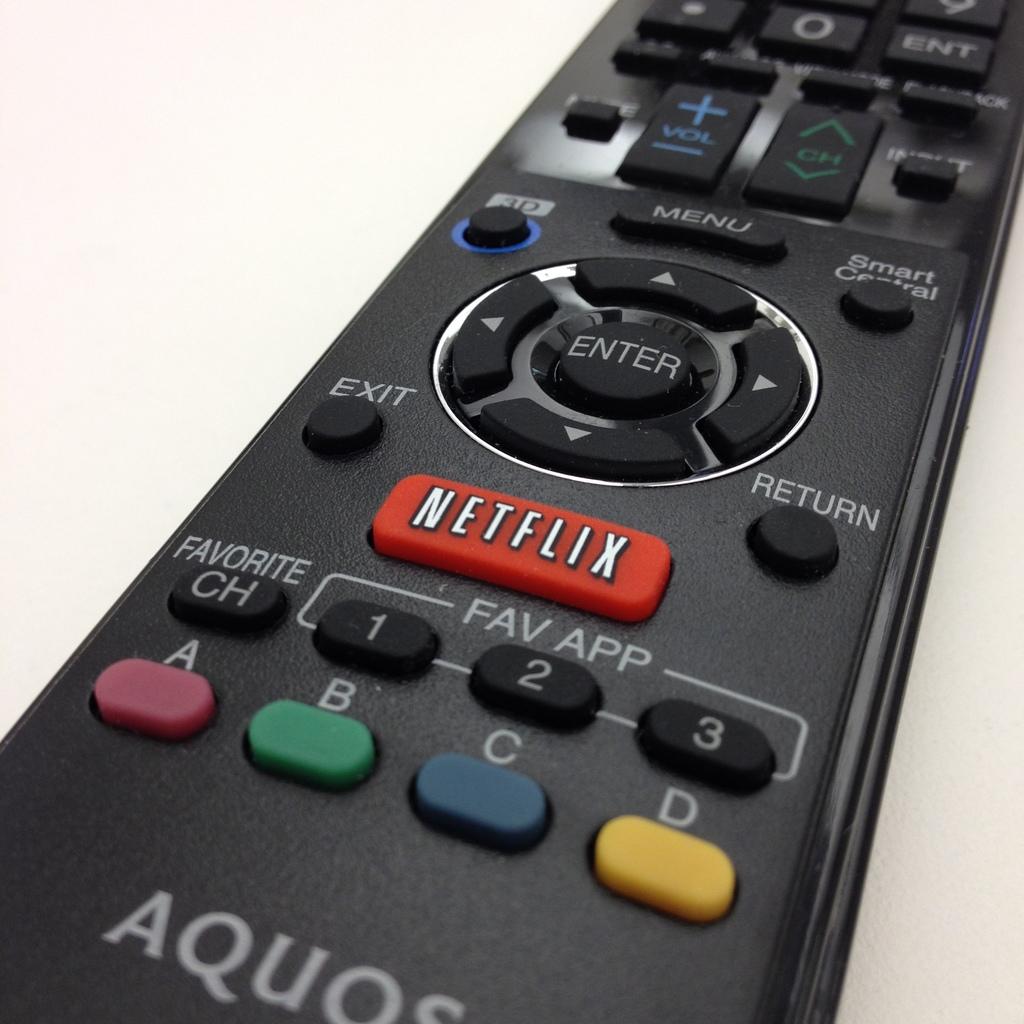What brand is this remote?
Ensure brevity in your answer.  Aquos. What streaming service has its own red button?
Provide a succinct answer. Netflix. 